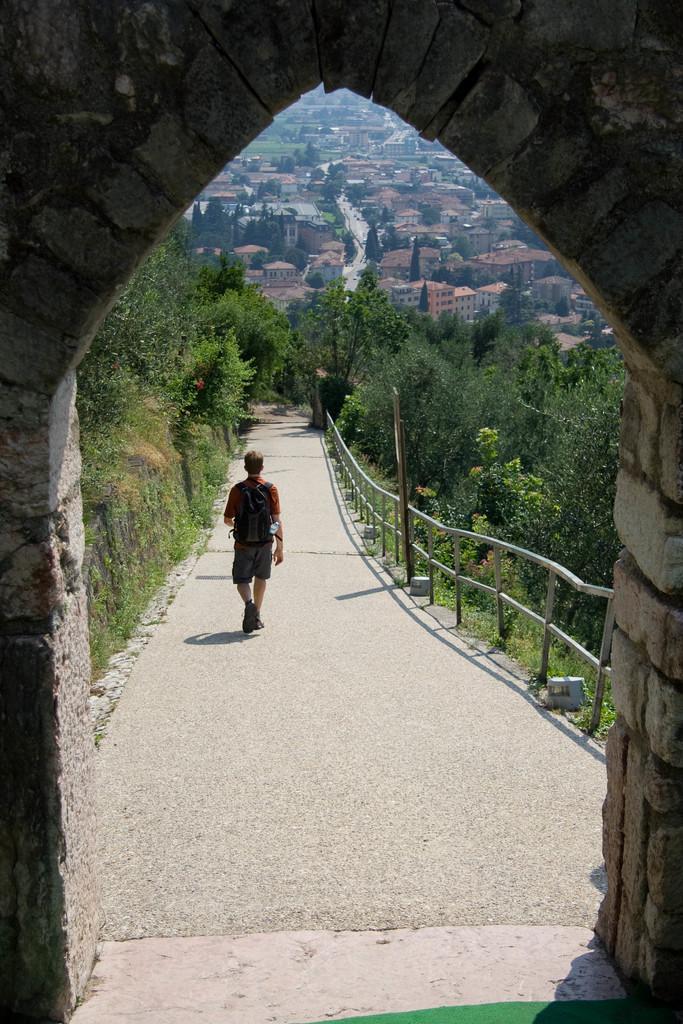Describe this image in one or two sentences. In front of the picture, we see an arch. In the middle of the picture, we see a man who is wearing the black backpack is walking on the road. Beside him, we see the road railing and a pole. On either side of the road, we see the trees. There are trees and buildings in the background. 